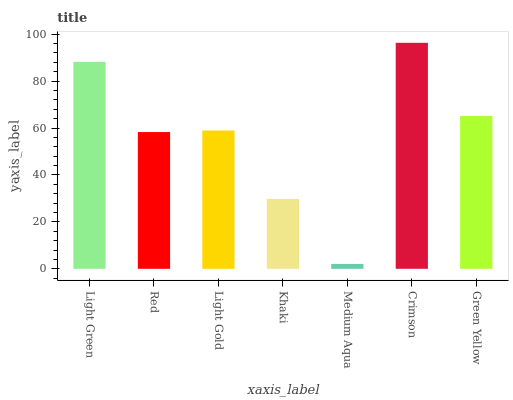Is Medium Aqua the minimum?
Answer yes or no. Yes. Is Crimson the maximum?
Answer yes or no. Yes. Is Red the minimum?
Answer yes or no. No. Is Red the maximum?
Answer yes or no. No. Is Light Green greater than Red?
Answer yes or no. Yes. Is Red less than Light Green?
Answer yes or no. Yes. Is Red greater than Light Green?
Answer yes or no. No. Is Light Green less than Red?
Answer yes or no. No. Is Light Gold the high median?
Answer yes or no. Yes. Is Light Gold the low median?
Answer yes or no. Yes. Is Medium Aqua the high median?
Answer yes or no. No. Is Crimson the low median?
Answer yes or no. No. 